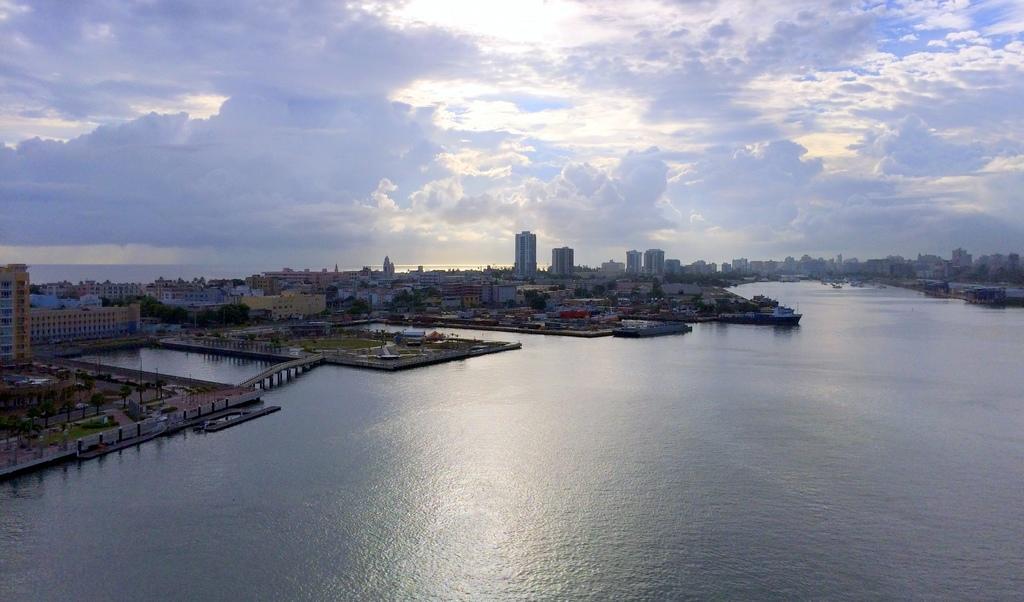In one or two sentences, can you explain what this image depicts? In the image there is water. There are many buildings, trees, poles and also there is a bridge. At the top of the image there is a sky with clouds. 